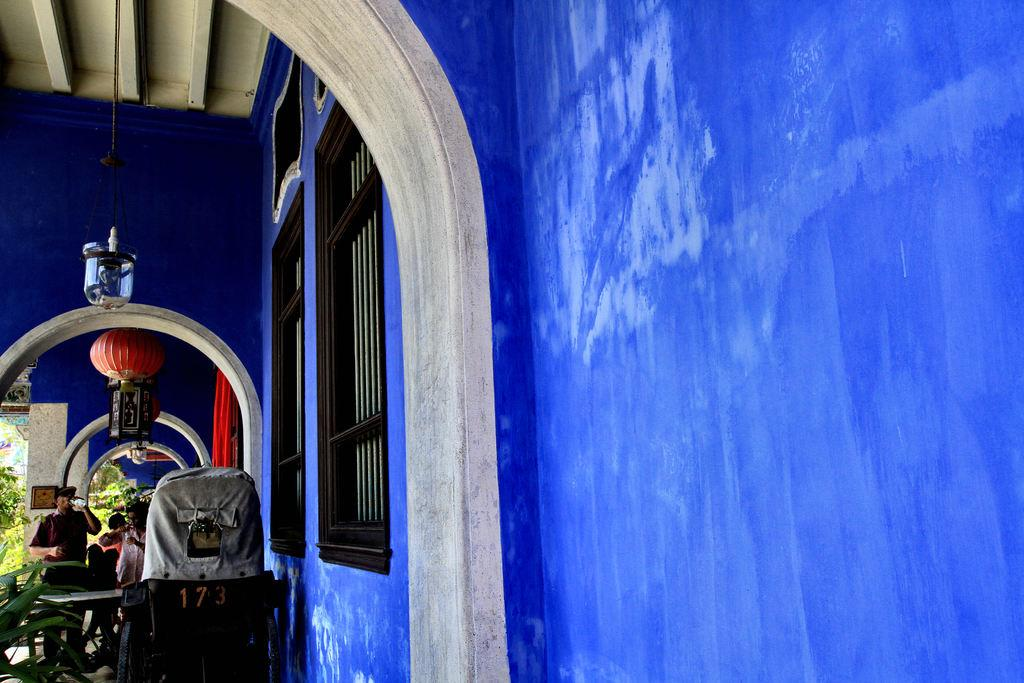What color is the wall in the image? There is a blue wall in the image. What can be seen in the image related to cooking or outdoor dining? There are grills in the image. Can you describe the people in the image? There are people in the image. What architectural features are present in the image? There are pillars in the image. What type of vegetation is visible in the image? There are plants and trees in the image. What decorative elements can be seen in the image? There are decorative items in the image. What type of lighting is present in the image? There are lights in the image. What type of rope is visible in the image? There is a rope in the image. What type of mobility aid is present in the image? There is a wheelchair in the image. What type of coil is used to hold the plants in the image? There is no coil present in the image; the plants are not held by any coil. In what year was the image taken? The year the image was taken is not mentioned in the provided facts. 